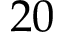<formula> <loc_0><loc_0><loc_500><loc_500>2 0</formula> 